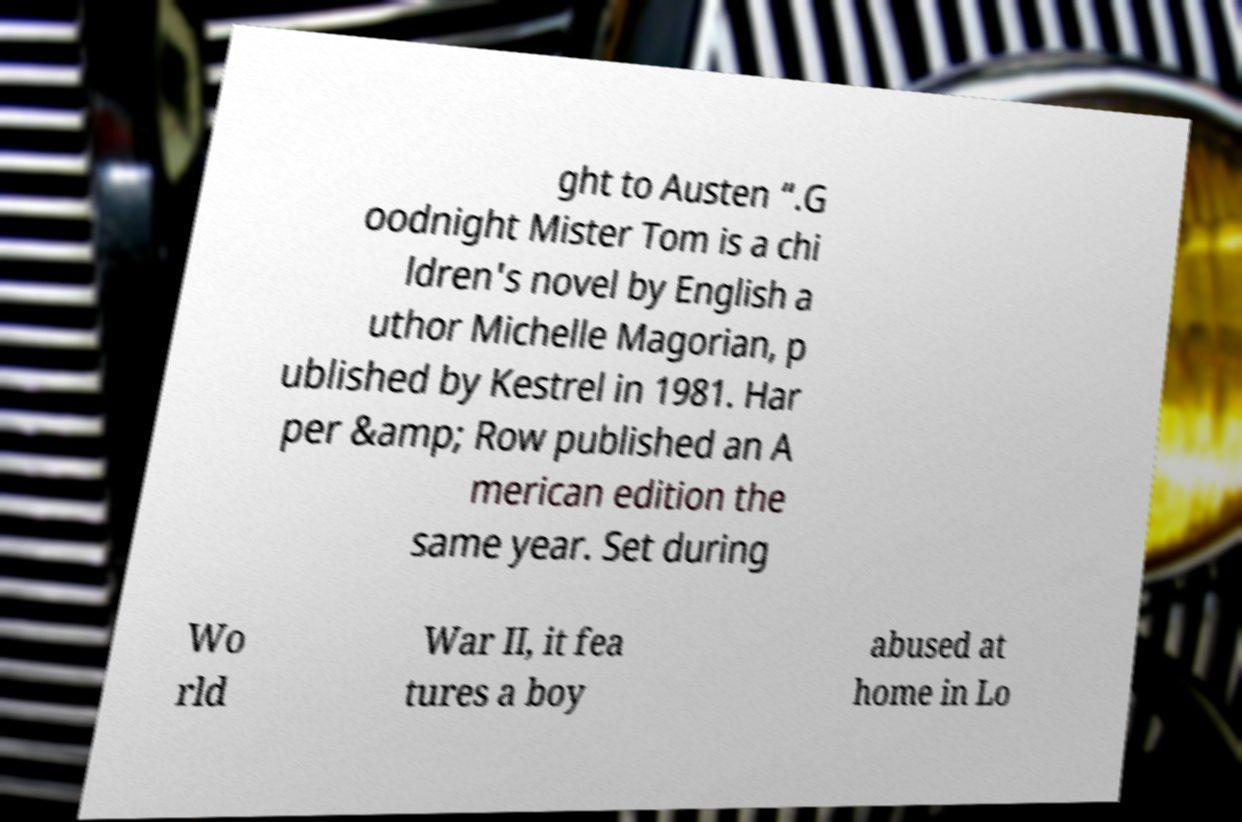I need the written content from this picture converted into text. Can you do that? ght to Austen “.G oodnight Mister Tom is a chi ldren's novel by English a uthor Michelle Magorian, p ublished by Kestrel in 1981. Har per &amp; Row published an A merican edition the same year. Set during Wo rld War II, it fea tures a boy abused at home in Lo 